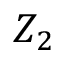Convert formula to latex. <formula><loc_0><loc_0><loc_500><loc_500>Z _ { 2 }</formula> 